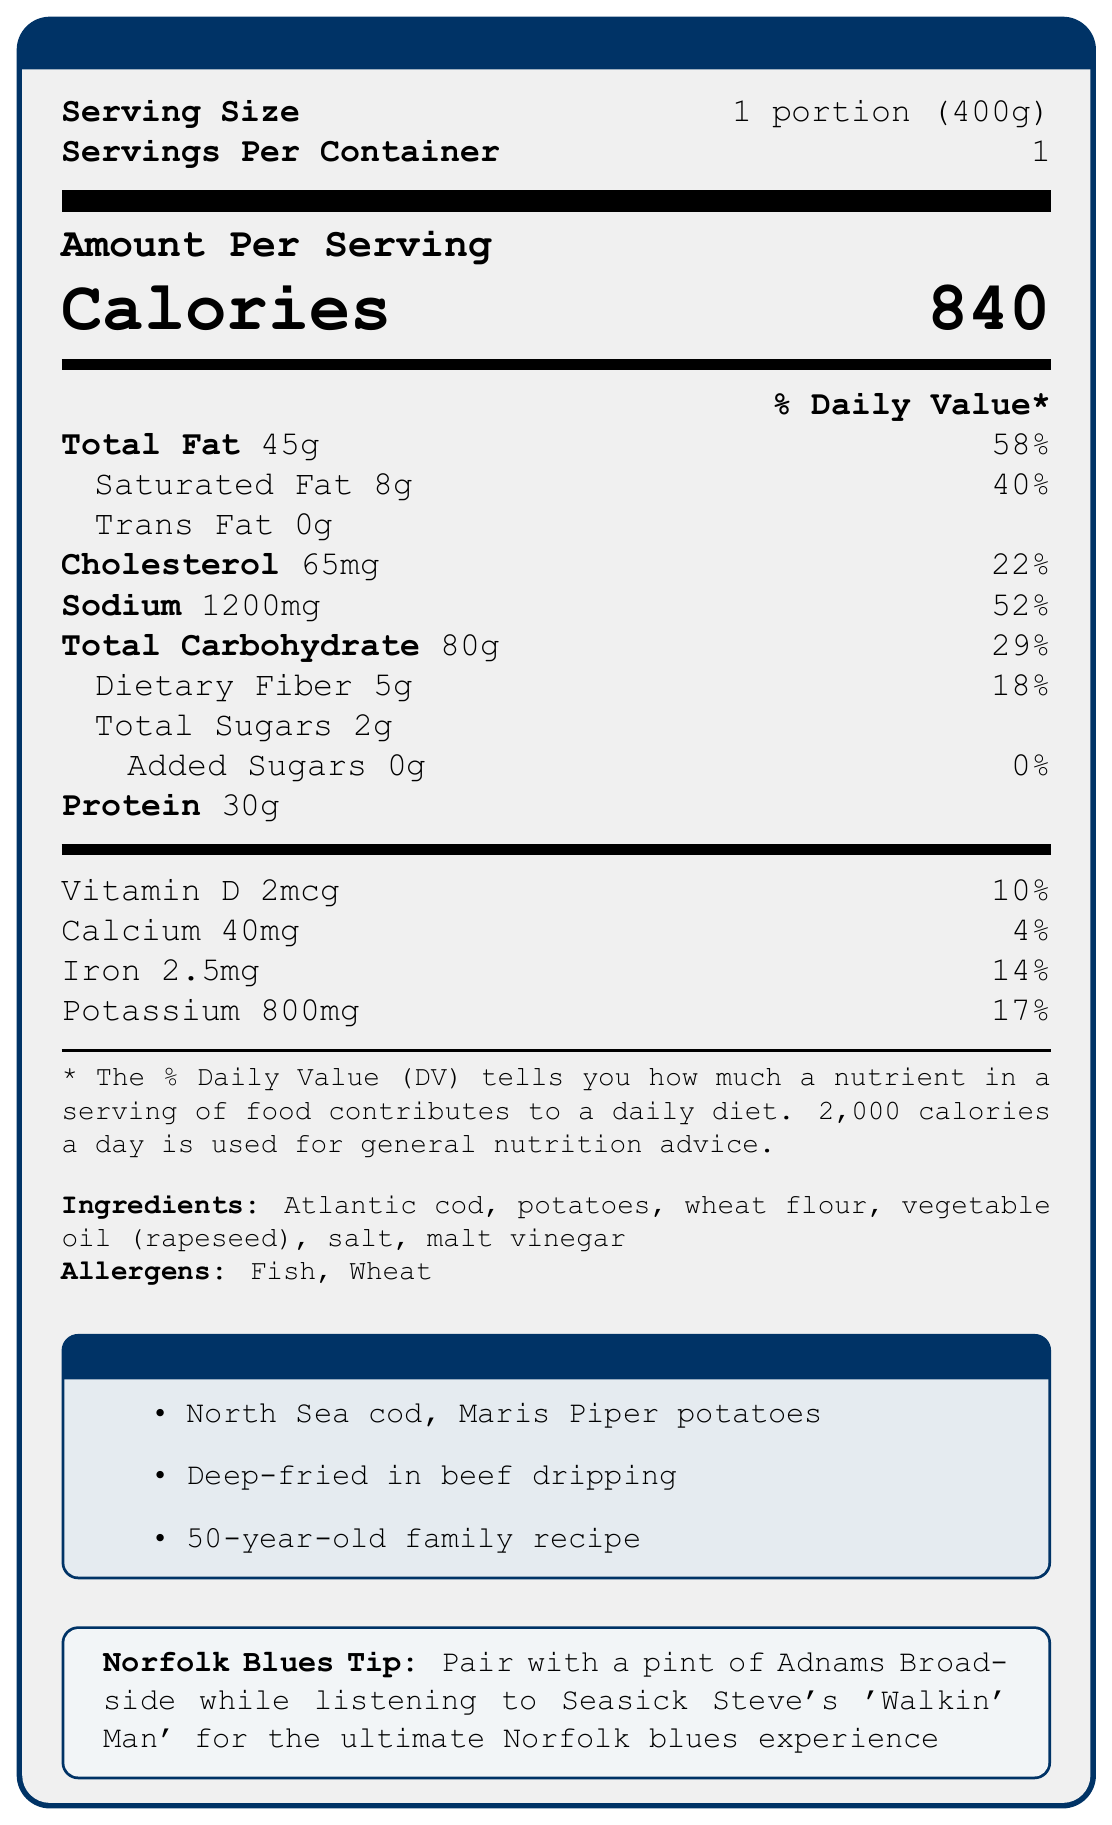what is the serving size? The document states that the serving size for the meal is 1 portion, which weighs 400 grams.
Answer: 1 portion (400g) how many calories are in one serving? The document shows that one serving contains 840 calories.
Answer: 840 calories list the main ingredients of the fish and chips meal According to the document, the main ingredients are listed as Atlantic cod, potatoes, wheat flour, vegetable oil (rapeseed), salt, and malt vinegar.
Answer: Atlantic cod, potatoes, wheat flour, vegetable oil (rapeseed), salt, malt vinegar what are the allergens mentioned in the document? The document specifies that the meal contains Fish and Wheat as allergens.
Answer: Fish, Wheat how much saturated fat is in one serving? The amount of saturated fat per serving is detailed in the document as 8 grams.
Answer: 8g which nutrient has the highest daily value percentage? A. Cholesterol B. Sodium C. Total Fat D. Protein Sodium has a Daily Value percentage of 52%, Cholesterol has 22%, and Total Fat has 58%. Protein's percentage is not listed. Therefore, Total Fat has the highest daily value percentage.
Answer: C what is the recommended pairing for the ultimate Norfolk blues experience? A. Pint of Guinness with blues harp music B. Pint of Adnams Broadside while listening to Seasick Steve's 'Walkin' Man' C. Cup of tea with a folk music CD D. Glass of wine with classical music The document suggests pairing the meal with a pint of Adnams Broadside while listening to Seasick Steve's 'Walkin' Man' for the best Norfolk blues experience.
Answer: B does the meal contain any added sugars? The document indicates that the meal contains 0 grams of added sugars, thus no added sugars are present.
Answer: No what is the source of the fish used in the meal? The document states that the Atlantic cod used in the meal is sourced from the North Sea.
Answer: North Sea how is the fish and chips cooked? According to the document, the cooking method for the fish and chips is deep-frying in beef dripping.
Answer: Deep-fried in beef dripping describe the nutritional content of this fish and chips meal in terms of fat, protein, and carbohydrates. The document includes detailed nutritional information, specifying in grams and percentage of Daily Value (% DV) the amounts of total fat, saturated fat, protein, carbohydrates, and dietary fiber.
Answer: This meal contains 45g of total fat (58% DV), including 8g of saturated fat (40% DV) and 30g of protein. It also has 80g of total carbohydrates (29% DV) with 5g from dietary fiber (18% DV). what is the vitamin D content in this meal? The document lists the vitamin D content as 2 micrograms (mcg).
Answer: 2mcg identify the restaurant that serves this traditional British fish and chips meal The document indicates that the meal is served at "The Cod Father" located in Great Yarmouth, Norfolk.
Answer: The Cod Father in Great Yarmouth, Norfolk can you find the exact cooking temperature for deep-frying the fish and chips? The document does not provide the specific cooking temperature for deep-frying the fish and chips.
Answer: Not enough information how many grams of dietary fiber does this meal have? According to the document, the dietary fiber content is 5 grams per serving.
Answer: 5g compare the sodium content to the daily recommended value The document states that this meal provides 1200 milligrams of sodium, which is 52% of the daily recommended value.
Answer: 52% of the daily value is provided by 1200mg of sodium in this meal 